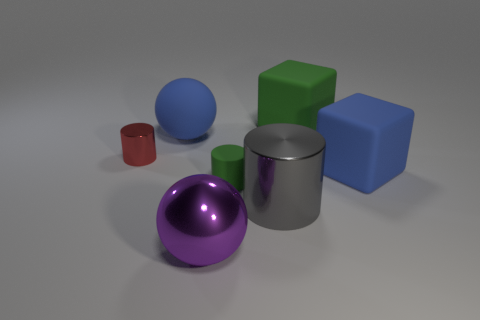Add 2 blue spheres. How many objects exist? 9 Subtract all balls. How many objects are left? 5 Add 6 big cyan matte cylinders. How many big cyan matte cylinders exist? 6 Subtract 0 cyan blocks. How many objects are left? 7 Subtract all big metal balls. Subtract all tiny yellow rubber balls. How many objects are left? 6 Add 2 purple shiny spheres. How many purple shiny spheres are left? 3 